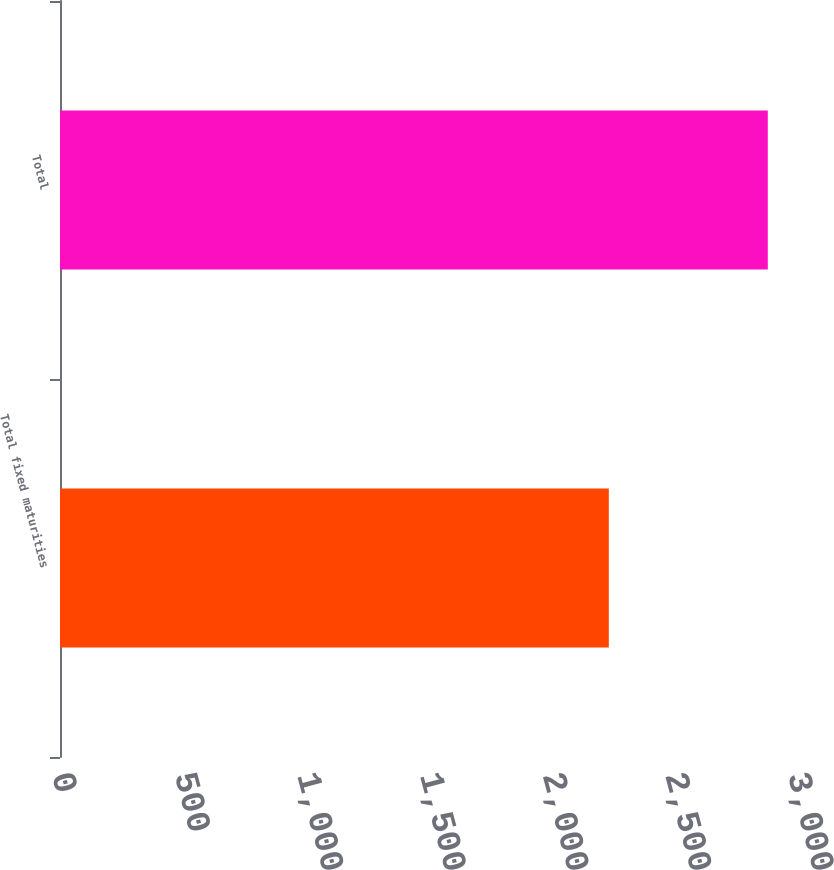Convert chart to OTSL. <chart><loc_0><loc_0><loc_500><loc_500><bar_chart><fcel>Total fixed maturities<fcel>Total<nl><fcel>2237<fcel>2885<nl></chart> 